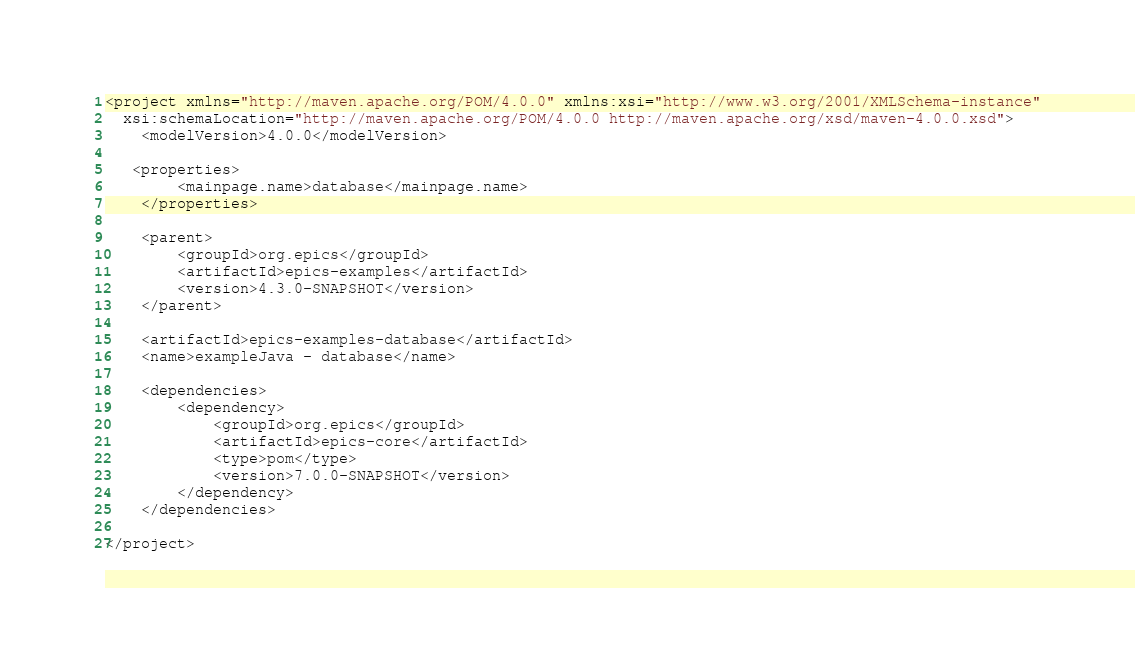Convert code to text. <code><loc_0><loc_0><loc_500><loc_500><_XML_><project xmlns="http://maven.apache.org/POM/4.0.0" xmlns:xsi="http://www.w3.org/2001/XMLSchema-instance"
  xsi:schemaLocation="http://maven.apache.org/POM/4.0.0 http://maven.apache.org/xsd/maven-4.0.0.xsd">
    <modelVersion>4.0.0</modelVersion>

   <properties>
        <mainpage.name>database</mainpage.name>
    </properties>

    <parent>
        <groupId>org.epics</groupId>
        <artifactId>epics-examples</artifactId>
        <version>4.3.0-SNAPSHOT</version>
    </parent>

    <artifactId>epics-examples-database</artifactId>
    <name>exampleJava - database</name>

    <dependencies>
        <dependency>
            <groupId>org.epics</groupId>
            <artifactId>epics-core</artifactId>
            <type>pom</type>
            <version>7.0.0-SNAPSHOT</version>
        </dependency>
    </dependencies>

</project>
</code> 